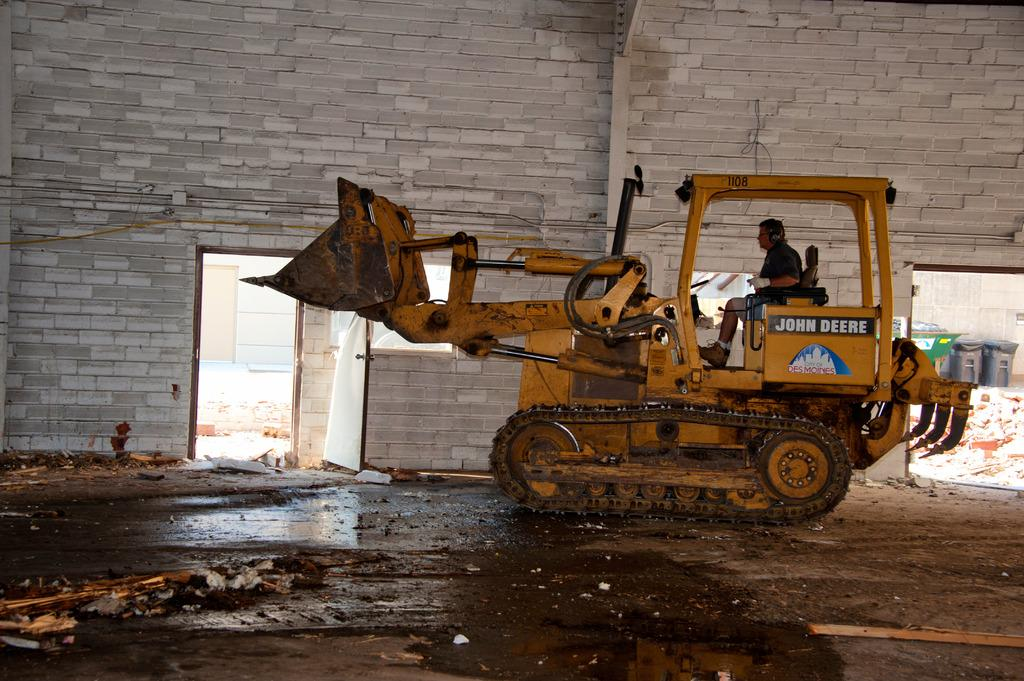What type of vehicle is in the image? There is a house breaking equipment vehicle in the image. Who is driving the vehicle? A man is driving the vehicle. What can be seen behind the vehicle? There is a wall with bricks visible behind the vehicle. What is located near the wall? There are dustbins outside the wall. What book is the beginner reading in the image? There is no book or person reading in the image. 